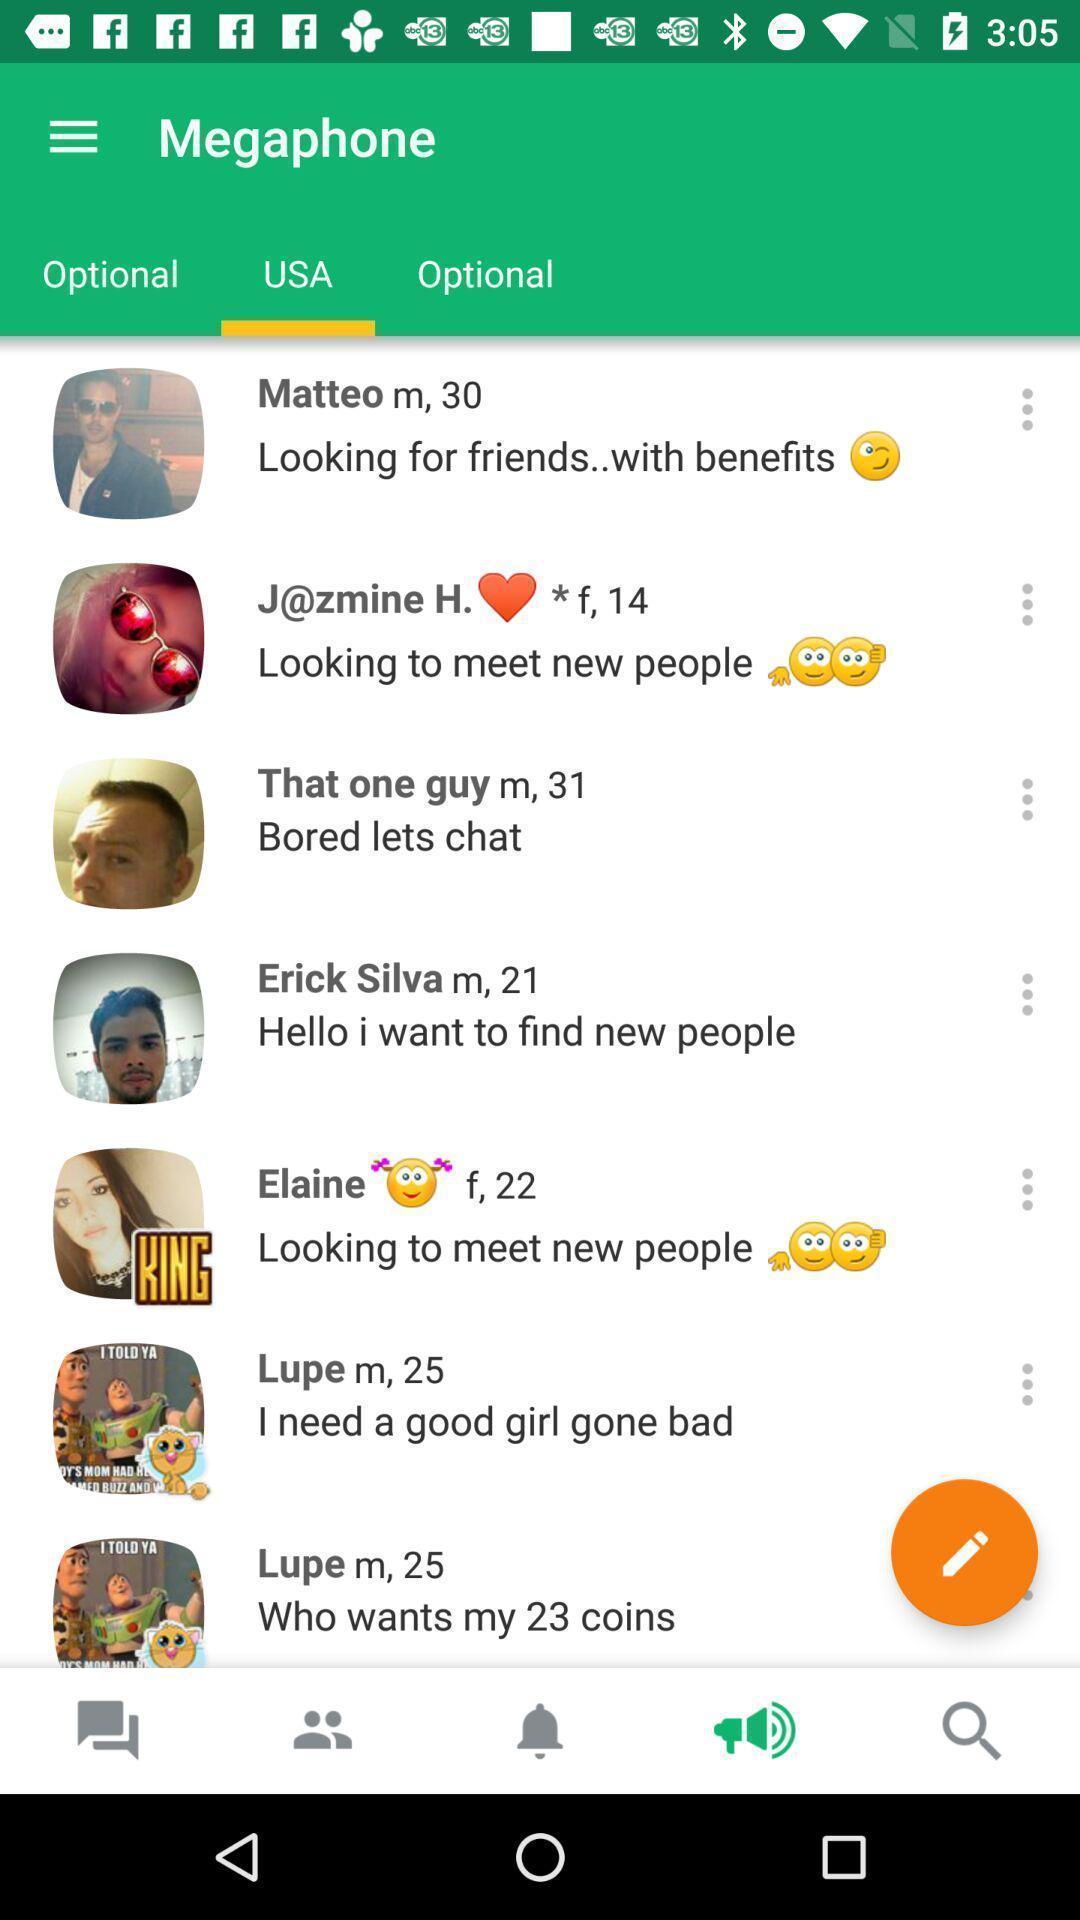Provide a description of this screenshot. Various persons profiles in the online application. 